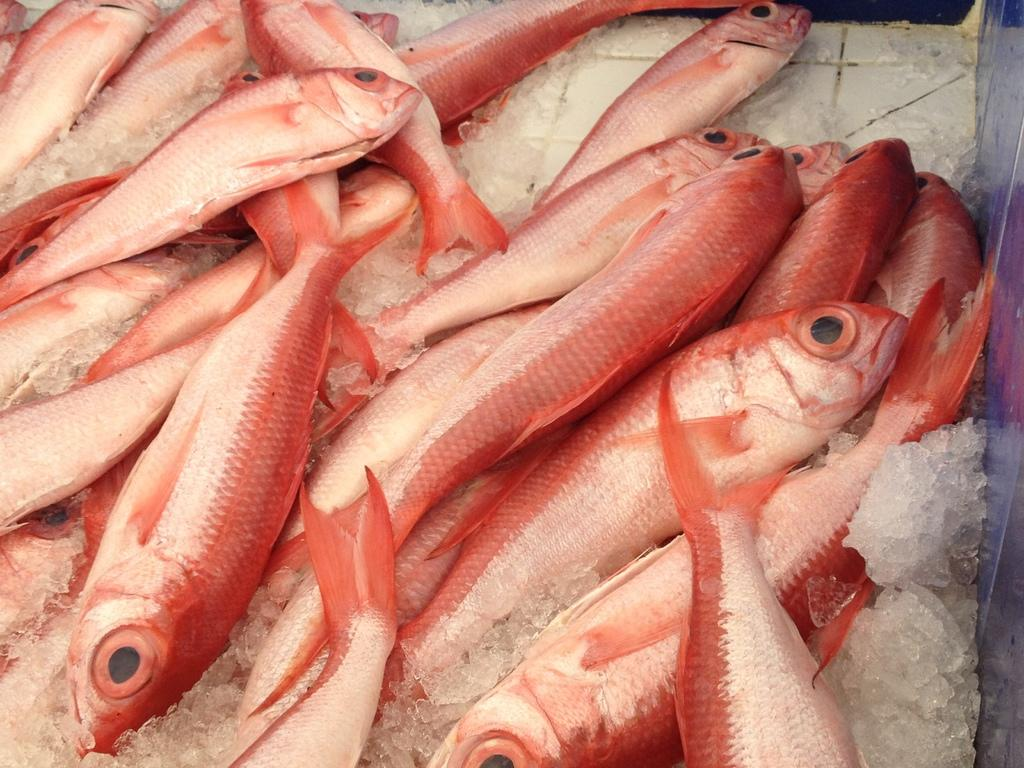What type of animals are in the image? There are fishes in the image. What colors can be seen on the fishes? The fishes have a red and white color combination. How are the fishes arranged in the image? The fishes are arranged on ice pieces. What is the color of the background in the image? The background of the image is white. What type of wrench is being used to shape the governor in the image? There is no wrench or governor present in the image; it features fishes arranged on ice pieces. 